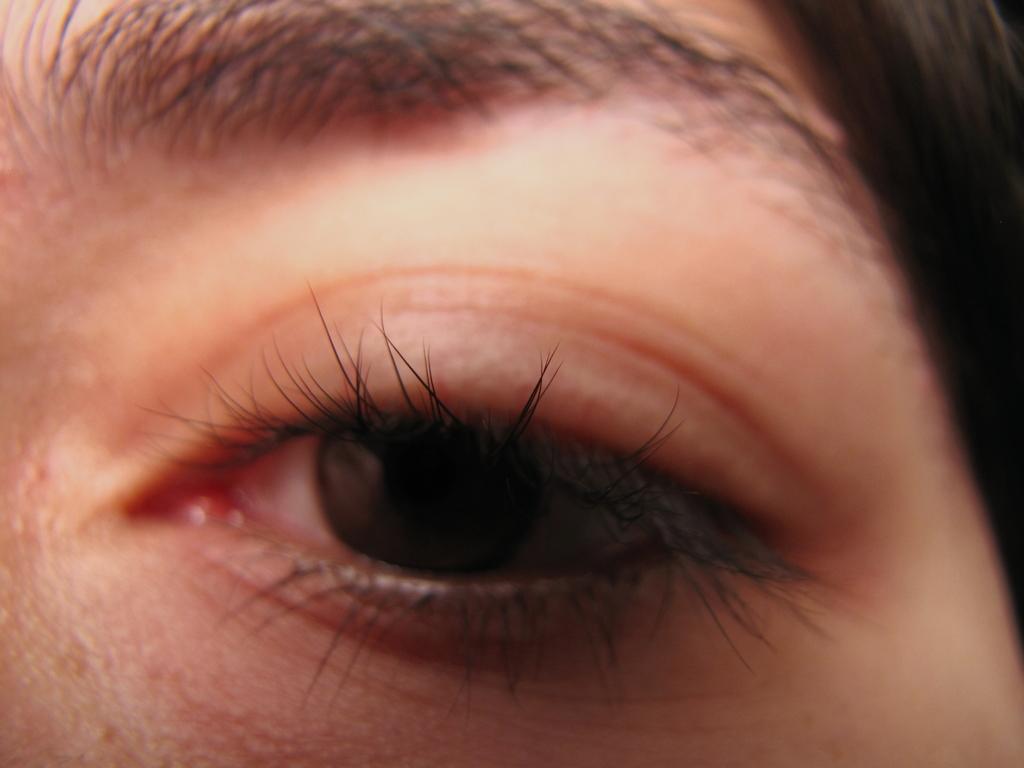How would you summarize this image in a sentence or two? In this image we can see an eye of a person. 